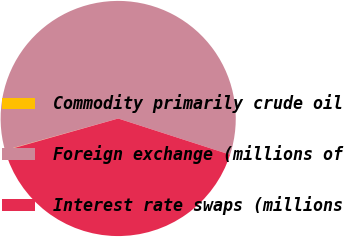Convert chart. <chart><loc_0><loc_0><loc_500><loc_500><pie_chart><fcel>Commodity primarily crude oil<fcel>Foreign exchange (millions of<fcel>Interest rate swaps (millions<nl><fcel>0.05%<fcel>59.33%<fcel>40.63%<nl></chart> 